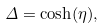Convert formula to latex. <formula><loc_0><loc_0><loc_500><loc_500>\Delta = \cosh ( \eta ) ,</formula> 